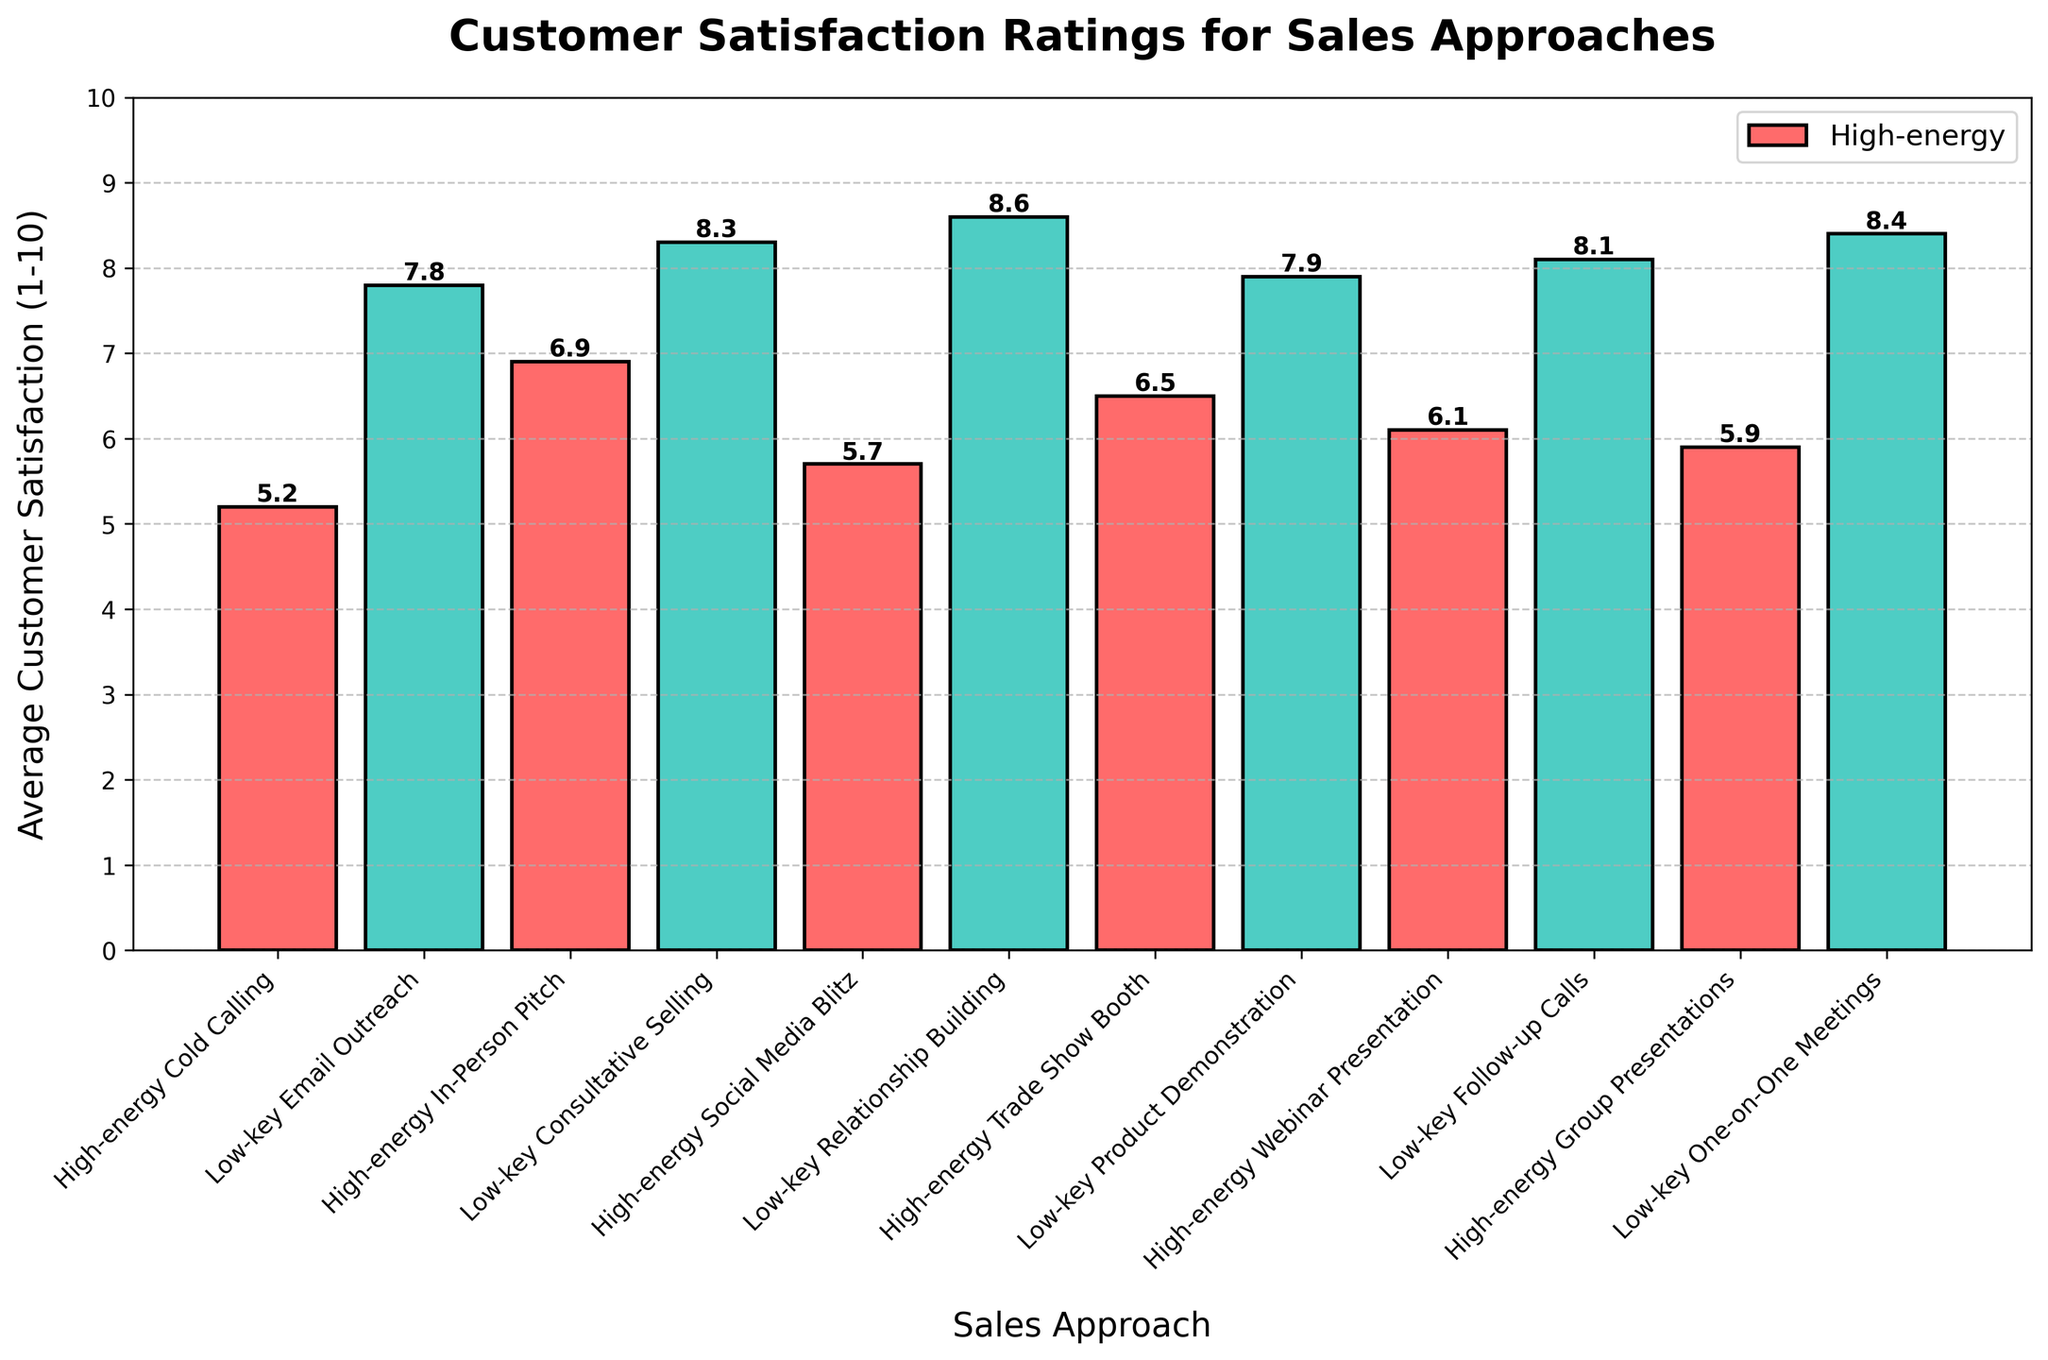what is the difference in customer satisfaction between the highest and lowest rated sales approaches? The highest-rated approach is "Low-key Relationship Building" with a satisfaction score of 8.6, and the lowest-rated approach is "High-energy Cold Calling" with a score of 5.2. The difference is calculated as 8.6 - 5.2.
Answer: 3.4 What sales approach had the second highest customer satisfaction rating? The highest rating is for "Low-key Relationship Building" (8.6), and the second highest is "Low-key One-on-One Meetings" with a satisfaction score of 8.4.
Answer: Low-key One-on-One Meetings Which sales approach has a higher average customer satisfaction rating: "High-energy In-Person Pitch" or "Low-key Product Demonstration"? "High-energy In-Person Pitch" has a satisfaction rating of 6.9, while "Low-key Product Demonstration" has a rating of 7.9. 7.9 is higher than 6.9.
Answer: Low-key Product Demonstration What's the average customer satisfaction rating for all low-key sales approaches? Add the ratings for all low-key approaches: 7.8 (Email Outreach) + 8.3 (Consultative Selling) + 8.6 (Relationship Building) + 7.9 (Product Demonstration) + 8.1 (Follow-up Calls) + 8.4 (One-on-One Meetings). The sum is 49.1, and there are 6 approaches. The average is 49.1/6.
Answer: 8.2 Which color represents the highest customer satisfaction rating in the figure? The highest customer satisfaction rating is 8.6 for "Low-key Relationship Building," and the color representing low-key approaches in the visualization is green.
Answer: Green 